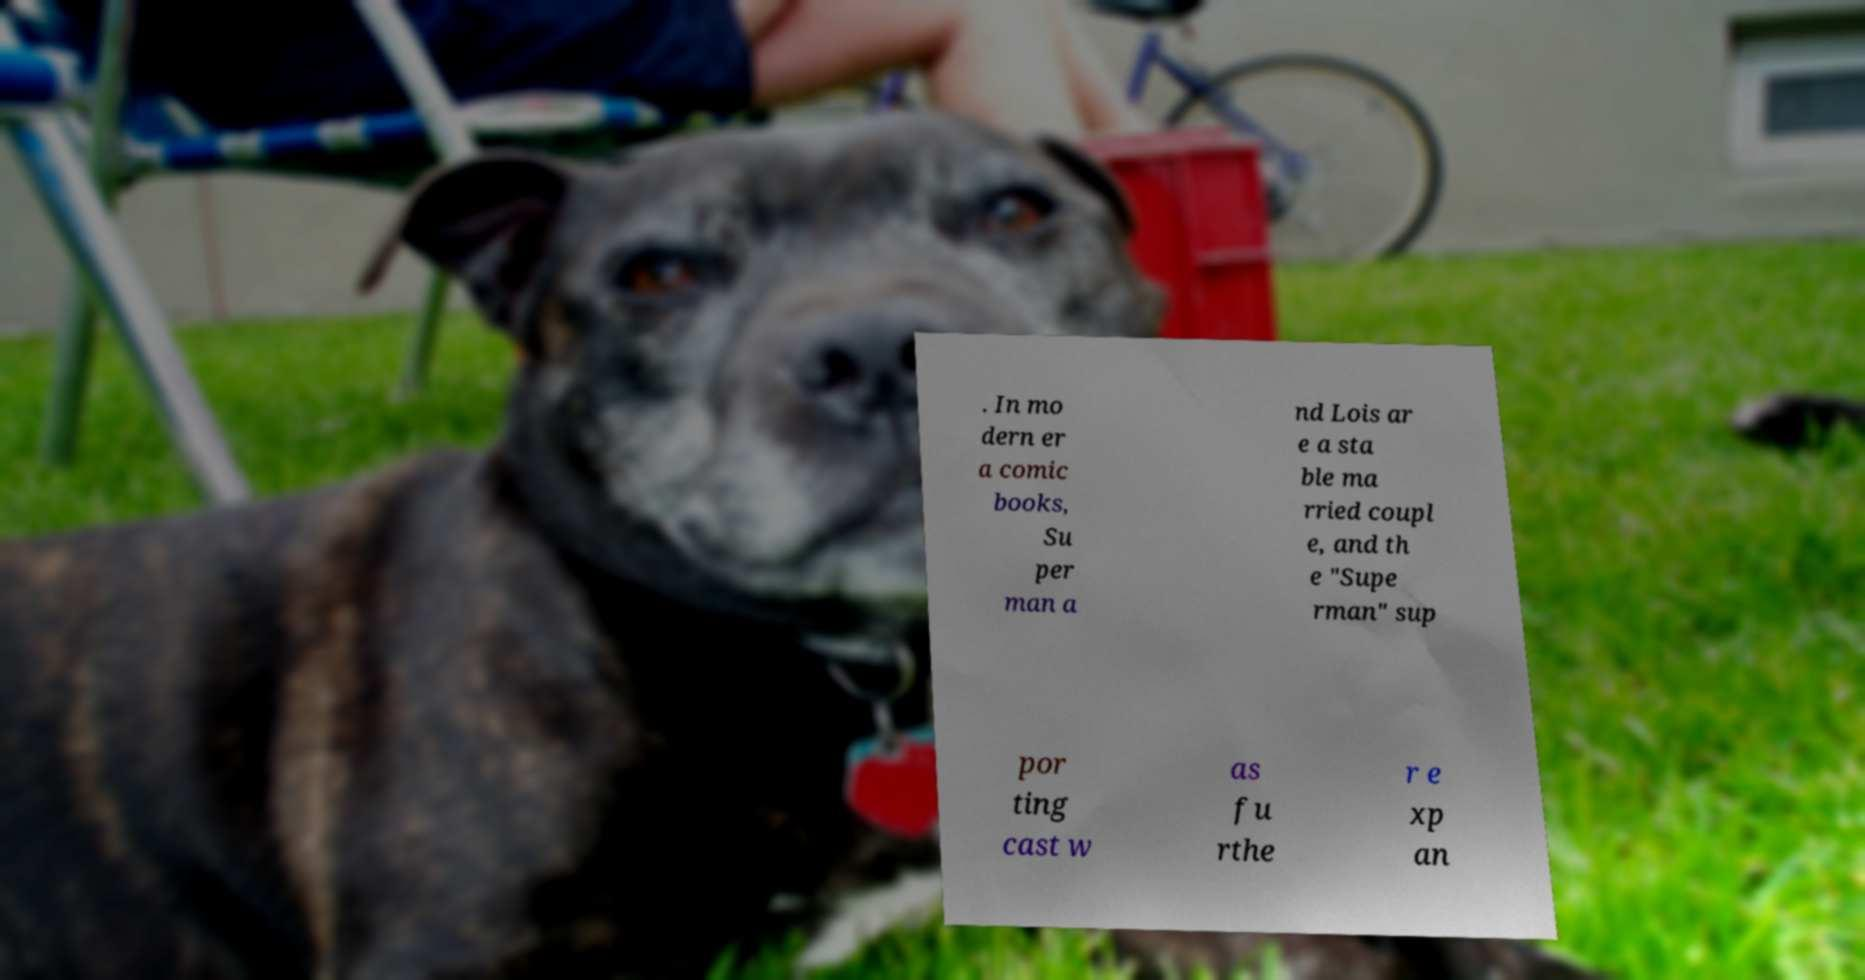Can you accurately transcribe the text from the provided image for me? . In mo dern er a comic books, Su per man a nd Lois ar e a sta ble ma rried coupl e, and th e "Supe rman" sup por ting cast w as fu rthe r e xp an 